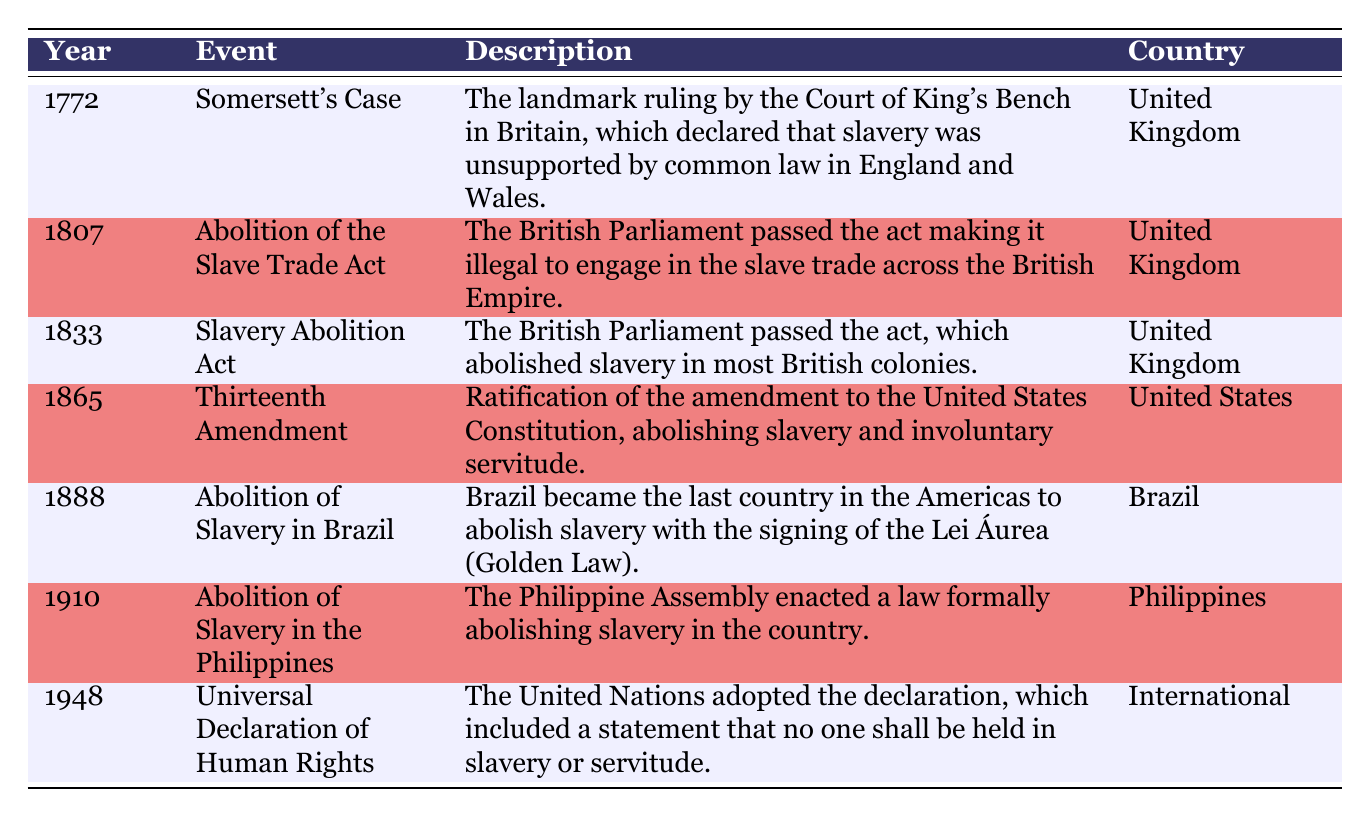What event occurred in 1807? The table indicates that in 1807, the British Parliament passed the Abolition of the Slave Trade Act, making it illegal to engage in the slave trade across the British Empire.
Answer: Abolition of the Slave Trade Act Which country was the last to abolish slavery in the Americas? According to the table, Brazil was the last country in the Americas to abolish slavery with the signing of the Lei Áurea in 1888.
Answer: Brazil How many years passed between the Somersett's Case and the Thirteenth Amendment? The Somersett's Case occurred in 1772 and the Thirteenth Amendment was ratified in 1865. To find the difference, subtract 1772 from 1865, which gives us 93 years.
Answer: 93 years Did the Universal Declaration of Human Rights include a statement about slavery? Yes, the table specifies that the Universal Declaration of Human Rights adopted in 1948 includes a statement that no one shall be held in slavery or servitude.
Answer: Yes What are the two events that took place in the 19th century? By reviewing the table, two events from the 19th century are the Slavery Abolition Act in 1833 and the Abolition of Slavery in Brazil in 1888.
Answer: Slavery Abolition Act and Abolition of Slavery in Brazil How many countries are represented in the table? The table shows entries from four different countries: the United Kingdom, the United States, Brazil, and the Philippines. Therefore, there are four countries represented.
Answer: Four countries What was the event listed for 1910? The table states that in 1910, the Philippine Assembly enacted a law formally abolishing slavery in the Philippines.
Answer: Abolition of Slavery in the Philippines What is the average year in which the events occurred? To find the average year, we sum all the years: 1772 + 1807 + 1833 + 1865 + 1888 + 1910 + 1948 = 13023. There are seven events, so divide 13023 by 7 to get approximately 1860.43.
Answer: Approximately 1860 Was the landmark ruling in the Somersett's Case supportive of slavery? No, the table notes that the Somersett's Case declared that slavery was unsupported by common law in England and Wales, meaning it was against it.
Answer: No 